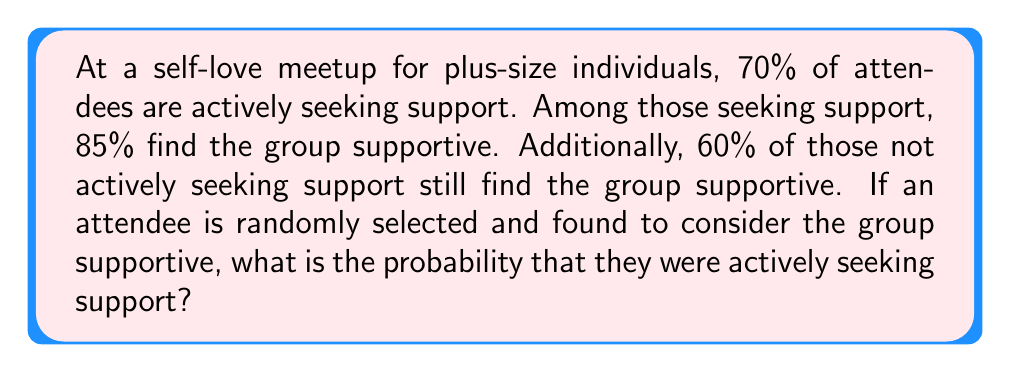Provide a solution to this math problem. Let's approach this problem using conditional probability. We'll define the following events:

A: The attendee is actively seeking support
S: The attendee finds the group supportive

We're given the following probabilities:

$P(A) = 0.70$
$P(S|A) = 0.85$
$P(S|\text{not }A) = 0.60$

We want to find $P(A|S)$, which can be calculated using Bayes' Theorem:

$$P(A|S) = \frac{P(S|A) \cdot P(A)}{P(S)}$$

To find $P(S)$, we can use the law of total probability:

$$P(S) = P(S|A) \cdot P(A) + P(S|\text{not }A) \cdot P(\text{not }A)$$

Let's calculate step by step:

1) $P(\text{not }A) = 1 - P(A) = 1 - 0.70 = 0.30$

2) $P(S) = 0.85 \cdot 0.70 + 0.60 \cdot 0.30 = 0.595 + 0.18 = 0.775$

3) Now we can apply Bayes' Theorem:

   $$P(A|S) = \frac{0.85 \cdot 0.70}{0.775} = \frac{0.595}{0.775} \approx 0.7677$$

Therefore, the probability that a randomly selected attendee who finds the group supportive was actively seeking support is approximately 0.7677 or 76.77%.
Answer: $P(A|S) \approx 0.7677$ or $76.77\%$ 